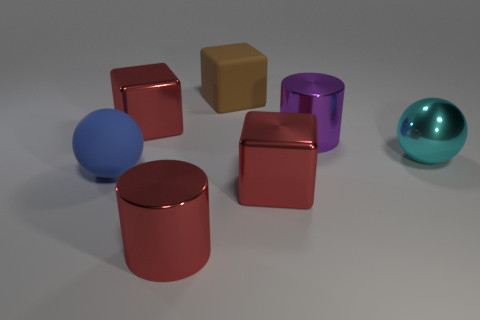Subtract all metal cubes. How many cubes are left? 1 Add 1 rubber objects. How many objects exist? 8 Subtract all red cubes. How many cubes are left? 1 Subtract all blue cylinders. How many red blocks are left? 2 Subtract 2 blocks. How many blocks are left? 1 Subtract all cylinders. How many objects are left? 5 Subtract all large brown balls. Subtract all red metal blocks. How many objects are left? 5 Add 3 blue matte balls. How many blue matte balls are left? 4 Add 4 red metal things. How many red metal things exist? 7 Subtract 0 gray balls. How many objects are left? 7 